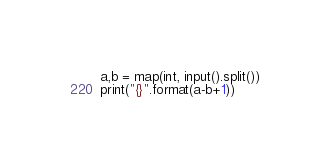Convert code to text. <code><loc_0><loc_0><loc_500><loc_500><_Python_>a,b = map(int, input().split())
print("{}".format(a-b+1))</code> 